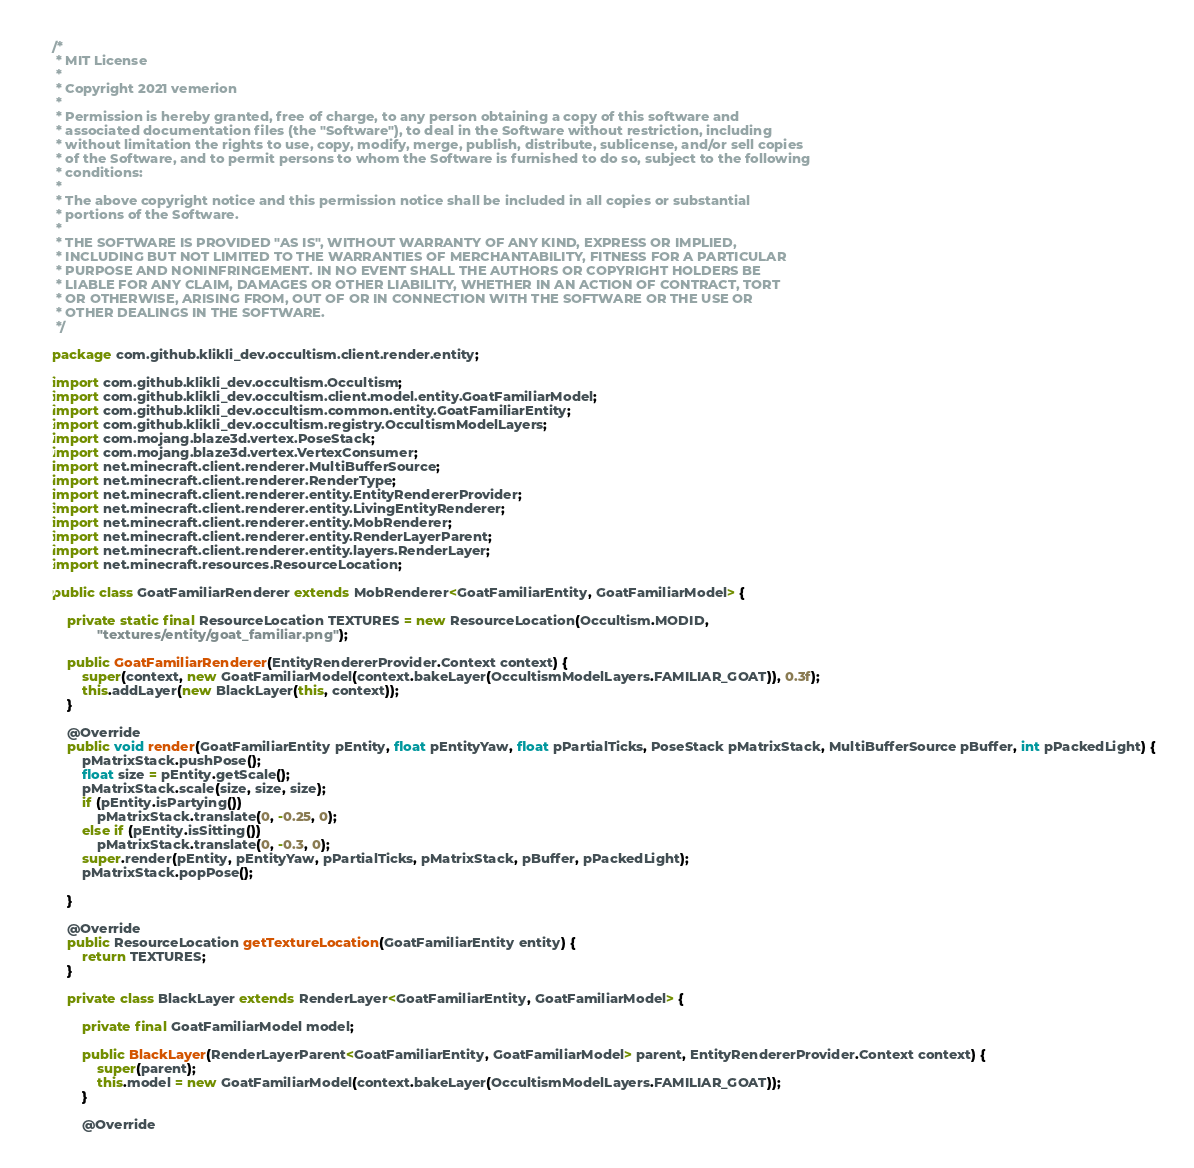Convert code to text. <code><loc_0><loc_0><loc_500><loc_500><_Java_>/*
 * MIT License
 *
 * Copyright 2021 vemerion
 *
 * Permission is hereby granted, free of charge, to any person obtaining a copy of this software and
 * associated documentation files (the "Software"), to deal in the Software without restriction, including
 * without limitation the rights to use, copy, modify, merge, publish, distribute, sublicense, and/or sell copies
 * of the Software, and to permit persons to whom the Software is furnished to do so, subject to the following
 * conditions:
 *
 * The above copyright notice and this permission notice shall be included in all copies or substantial
 * portions of the Software.
 *
 * THE SOFTWARE IS PROVIDED "AS IS", WITHOUT WARRANTY OF ANY KIND, EXPRESS OR IMPLIED,
 * INCLUDING BUT NOT LIMITED TO THE WARRANTIES OF MERCHANTABILITY, FITNESS FOR A PARTICULAR
 * PURPOSE AND NONINFRINGEMENT. IN NO EVENT SHALL THE AUTHORS OR COPYRIGHT HOLDERS BE
 * LIABLE FOR ANY CLAIM, DAMAGES OR OTHER LIABILITY, WHETHER IN AN ACTION OF CONTRACT, TORT
 * OR OTHERWISE, ARISING FROM, OUT OF OR IN CONNECTION WITH THE SOFTWARE OR THE USE OR
 * OTHER DEALINGS IN THE SOFTWARE.
 */

package com.github.klikli_dev.occultism.client.render.entity;

import com.github.klikli_dev.occultism.Occultism;
import com.github.klikli_dev.occultism.client.model.entity.GoatFamiliarModel;
import com.github.klikli_dev.occultism.common.entity.GoatFamiliarEntity;
import com.github.klikli_dev.occultism.registry.OccultismModelLayers;
import com.mojang.blaze3d.vertex.PoseStack;
import com.mojang.blaze3d.vertex.VertexConsumer;
import net.minecraft.client.renderer.MultiBufferSource;
import net.minecraft.client.renderer.RenderType;
import net.minecraft.client.renderer.entity.EntityRendererProvider;
import net.minecraft.client.renderer.entity.LivingEntityRenderer;
import net.minecraft.client.renderer.entity.MobRenderer;
import net.minecraft.client.renderer.entity.RenderLayerParent;
import net.minecraft.client.renderer.entity.layers.RenderLayer;
import net.minecraft.resources.ResourceLocation;

public class GoatFamiliarRenderer extends MobRenderer<GoatFamiliarEntity, GoatFamiliarModel> {

    private static final ResourceLocation TEXTURES = new ResourceLocation(Occultism.MODID,
            "textures/entity/goat_familiar.png");

    public GoatFamiliarRenderer(EntityRendererProvider.Context context) {
        super(context, new GoatFamiliarModel(context.bakeLayer(OccultismModelLayers.FAMILIAR_GOAT)), 0.3f);
        this.addLayer(new BlackLayer(this, context));
    }

    @Override
    public void render(GoatFamiliarEntity pEntity, float pEntityYaw, float pPartialTicks, PoseStack pMatrixStack, MultiBufferSource pBuffer, int pPackedLight) {
        pMatrixStack.pushPose();
        float size = pEntity.getScale();
        pMatrixStack.scale(size, size, size);
        if (pEntity.isPartying())
            pMatrixStack.translate(0, -0.25, 0);
        else if (pEntity.isSitting())
            pMatrixStack.translate(0, -0.3, 0);
        super.render(pEntity, pEntityYaw, pPartialTicks, pMatrixStack, pBuffer, pPackedLight);
        pMatrixStack.popPose();

    }

    @Override
    public ResourceLocation getTextureLocation(GoatFamiliarEntity entity) {
        return TEXTURES;
    }

    private class BlackLayer extends RenderLayer<GoatFamiliarEntity, GoatFamiliarModel> {

        private final GoatFamiliarModel model;

        public BlackLayer(RenderLayerParent<GoatFamiliarEntity, GoatFamiliarModel> parent, EntityRendererProvider.Context context) {
            super(parent);
            this.model = new GoatFamiliarModel(context.bakeLayer(OccultismModelLayers.FAMILIAR_GOAT));
        }

        @Override</code> 